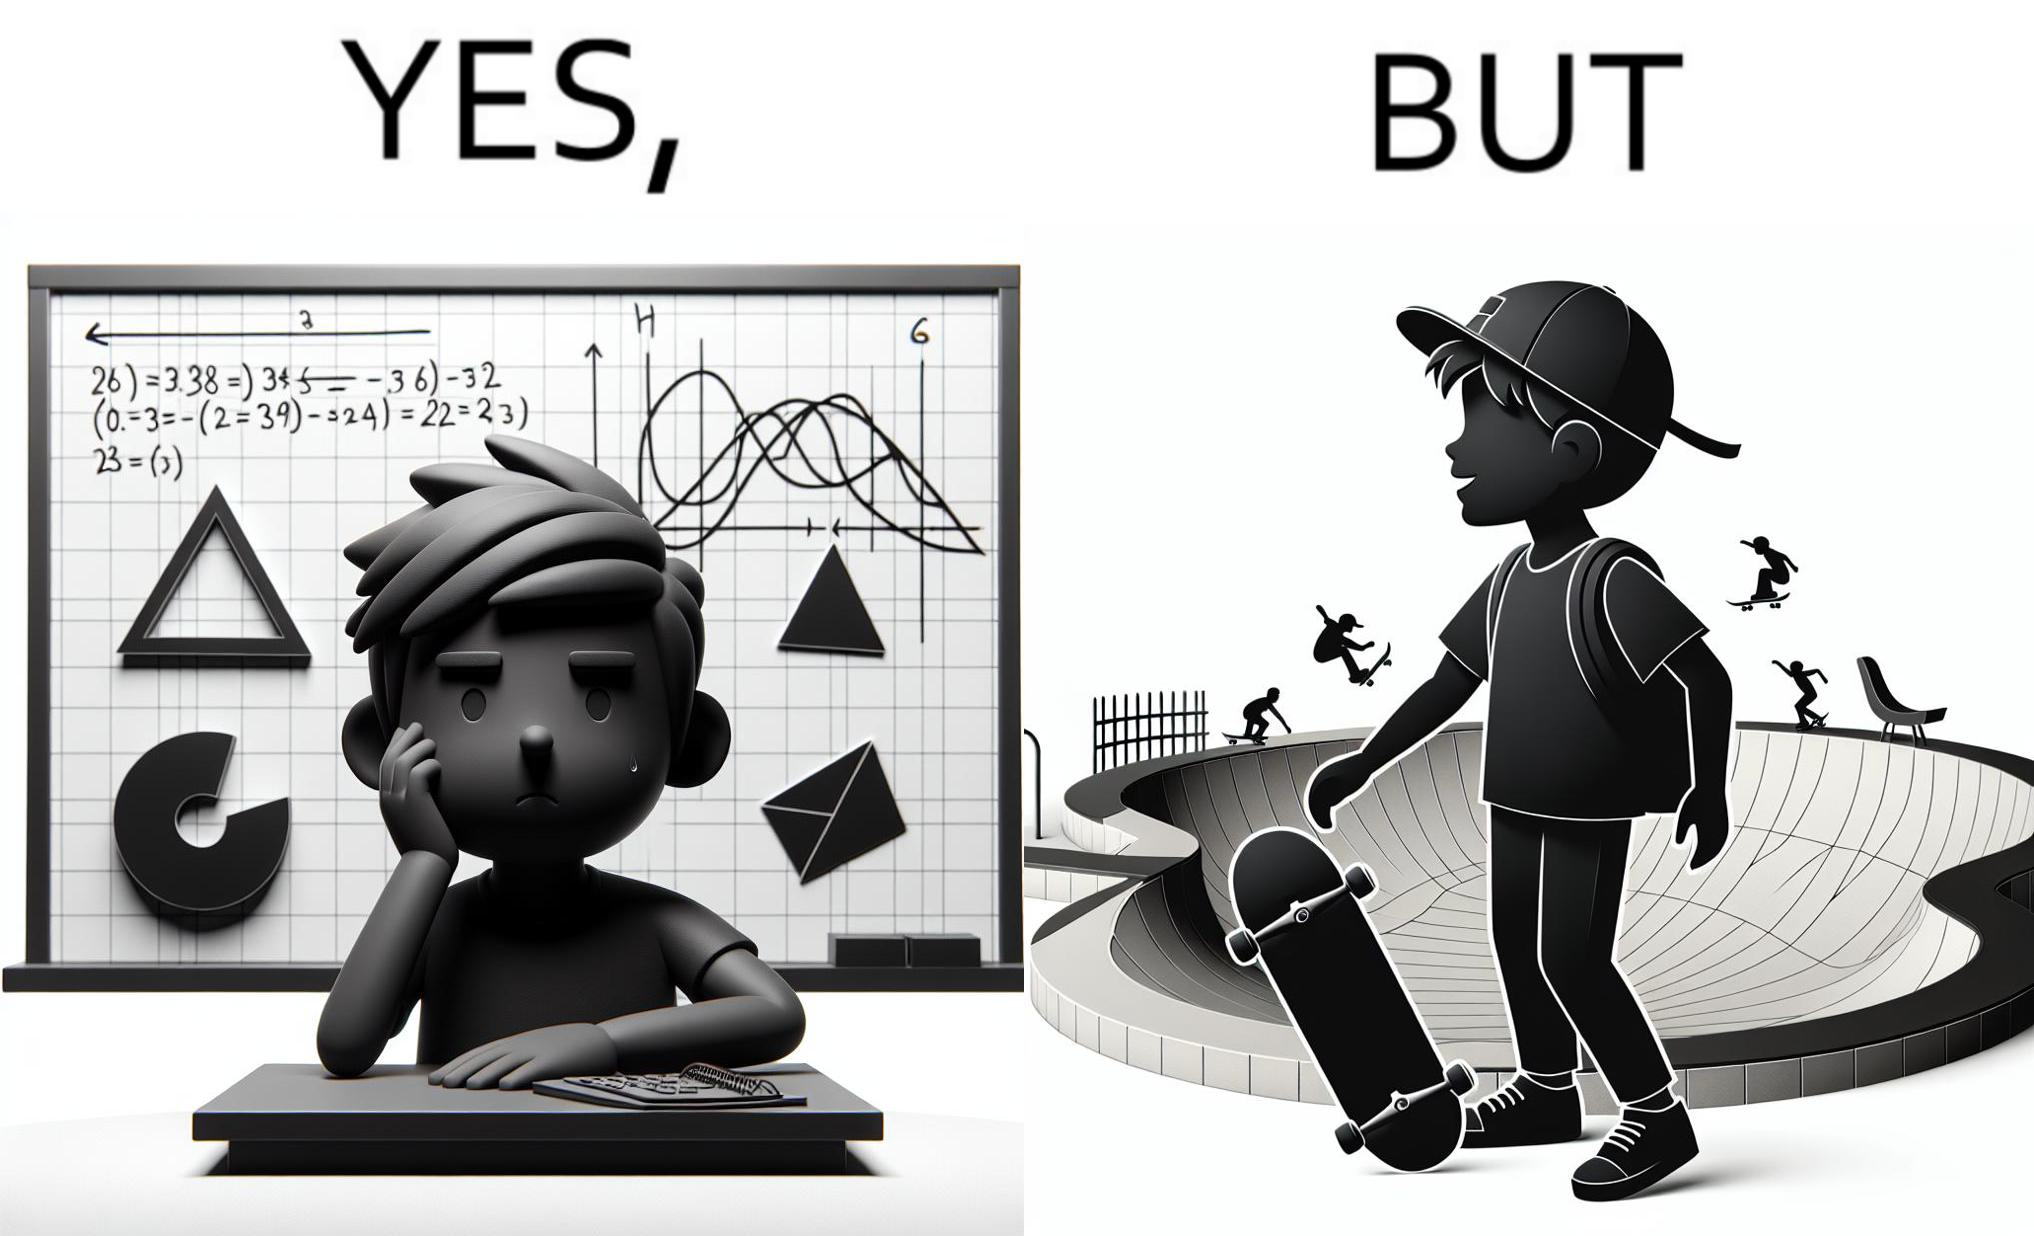Does this image contain satire or humor? Yes, this image is satirical. 